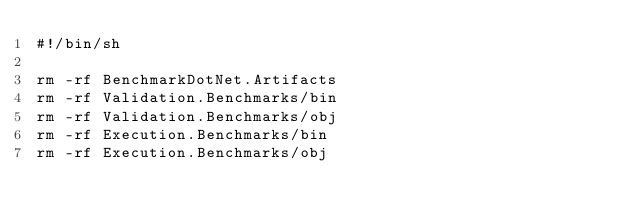Convert code to text. <code><loc_0><loc_0><loc_500><loc_500><_Bash_>#!/bin/sh

rm -rf BenchmarkDotNet.Artifacts
rm -rf Validation.Benchmarks/bin
rm -rf Validation.Benchmarks/obj
rm -rf Execution.Benchmarks/bin
rm -rf Execution.Benchmarks/obj
</code> 